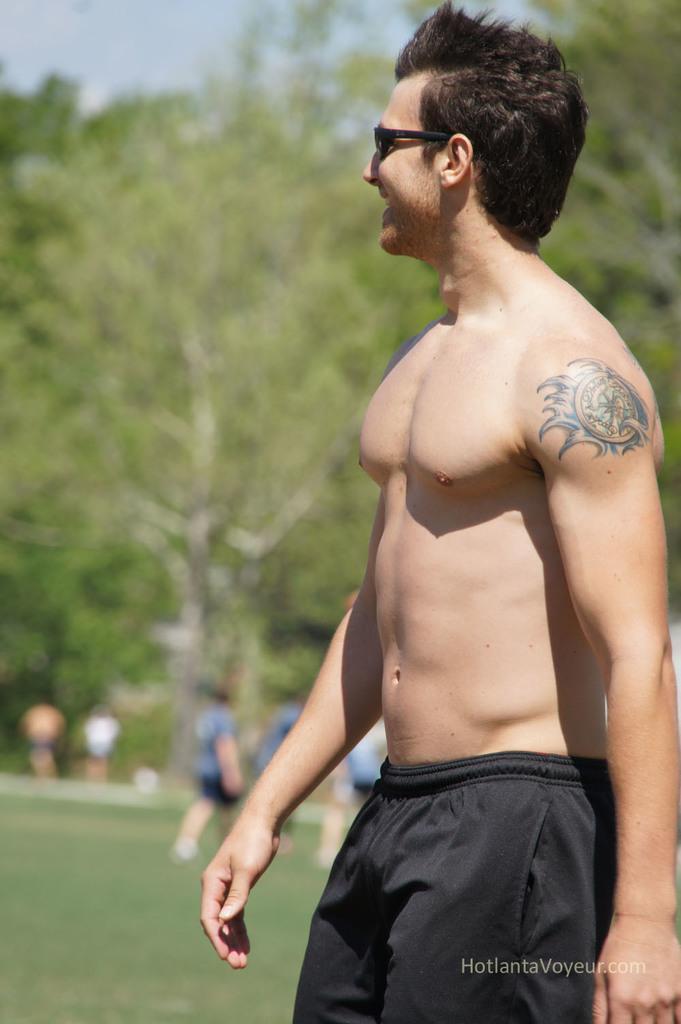Could you give a brief overview of what you see in this image? In this picture, there is a man towards the right. He is wearing black shorts. In the background, there are people, grass and trees. 